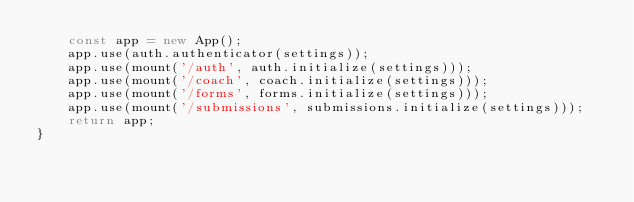Convert code to text. <code><loc_0><loc_0><loc_500><loc_500><_JavaScript_>    const app = new App();
    app.use(auth.authenticator(settings));
    app.use(mount('/auth', auth.initialize(settings)));
    app.use(mount('/coach', coach.initialize(settings)));
    app.use(mount('/forms', forms.initialize(settings)));
    app.use(mount('/submissions', submissions.initialize(settings)));
    return app;
}
</code> 